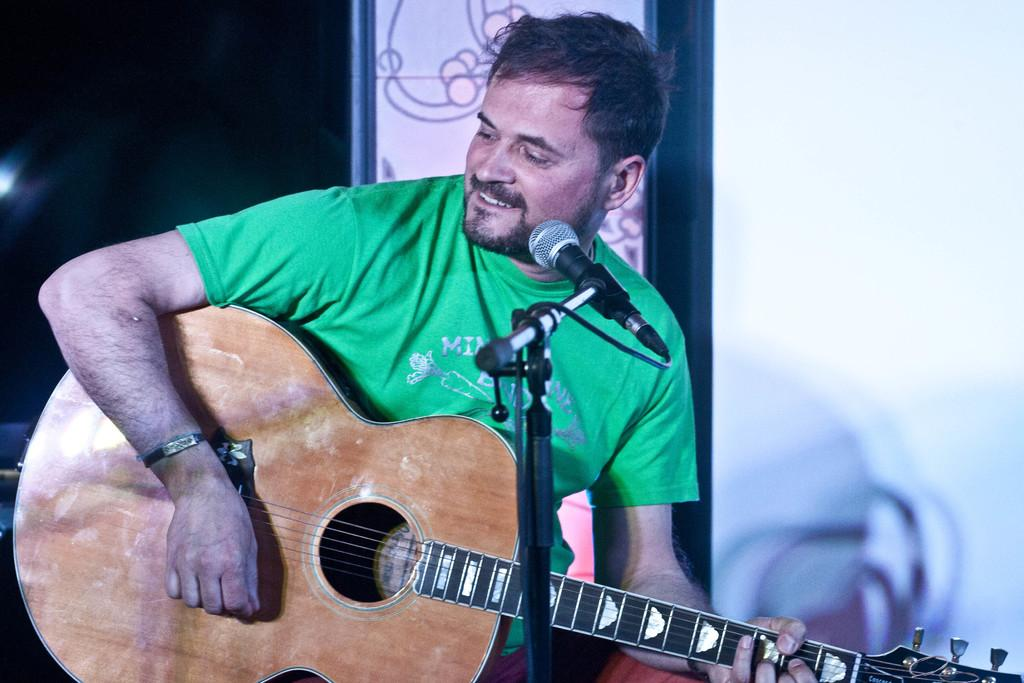What is the main subject of the image? The main subject of the image is a man. What is the man wearing in the image? The man is wearing a green t-shirt in the image. What is the man doing in the image? The man is sitting and playing a guitar in the image. What object is in front of the man? There is a microphone in front of the man in the image. What is the man's facial expression in the image? The man is smiling in the image. What type of store can be seen in the background of the image? There is no store visible in the image; it only features a man playing a guitar with a microphone in front of him. 